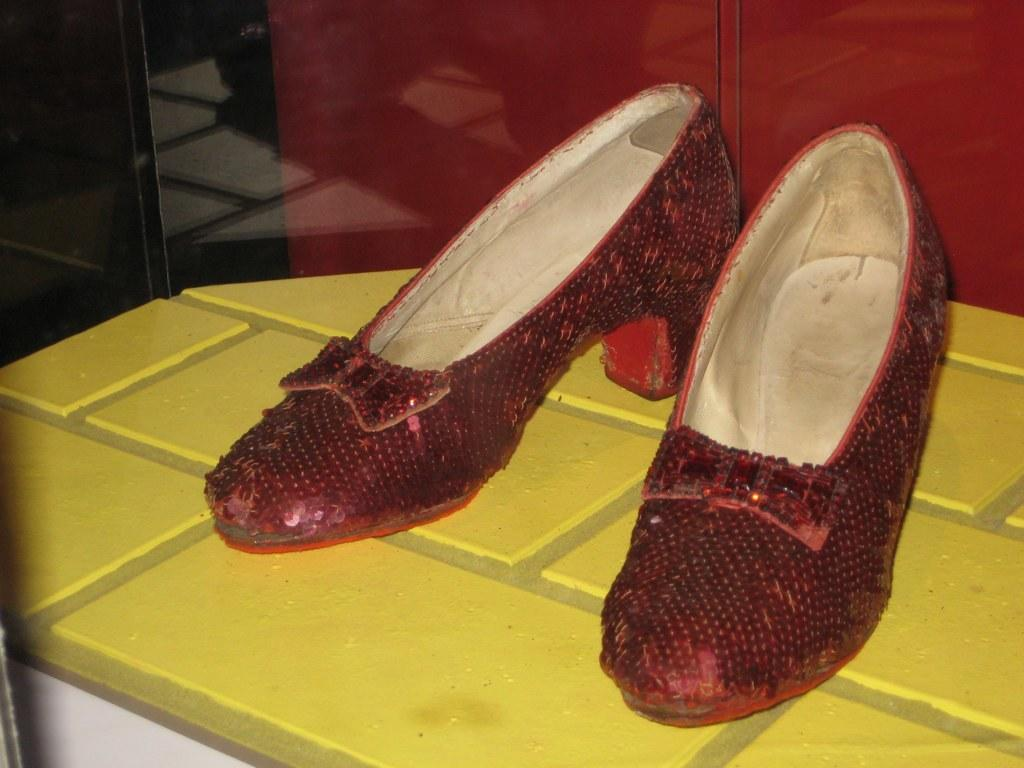What type of shoes are in the image? There are red color shoes in the image. Where are the shoes placed? The shoes are on a yellow color platform. What color is the wall in the background of the image? The wall in the background of the image is red color. What type of blade can be seen in the image? There is no blade present in the image. Is there a fire visible in the image? There is no fire visible in the image. 